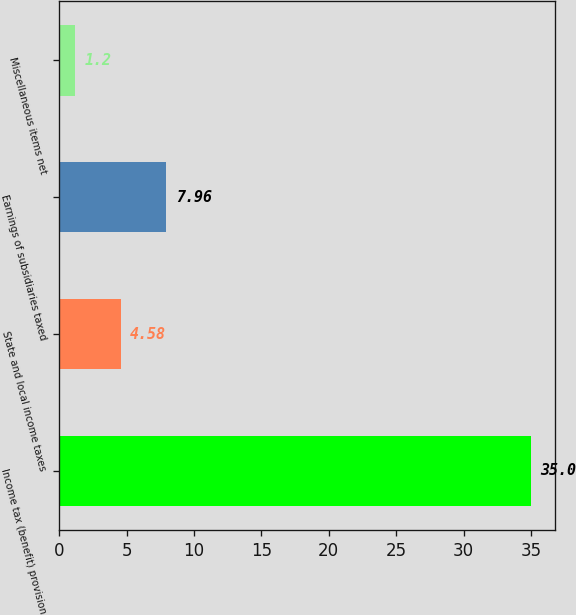Convert chart. <chart><loc_0><loc_0><loc_500><loc_500><bar_chart><fcel>Income tax (benefit) provision<fcel>State and local income taxes<fcel>Earnings of subsidiaries taxed<fcel>Miscellaneous items net<nl><fcel>35<fcel>4.58<fcel>7.96<fcel>1.2<nl></chart> 